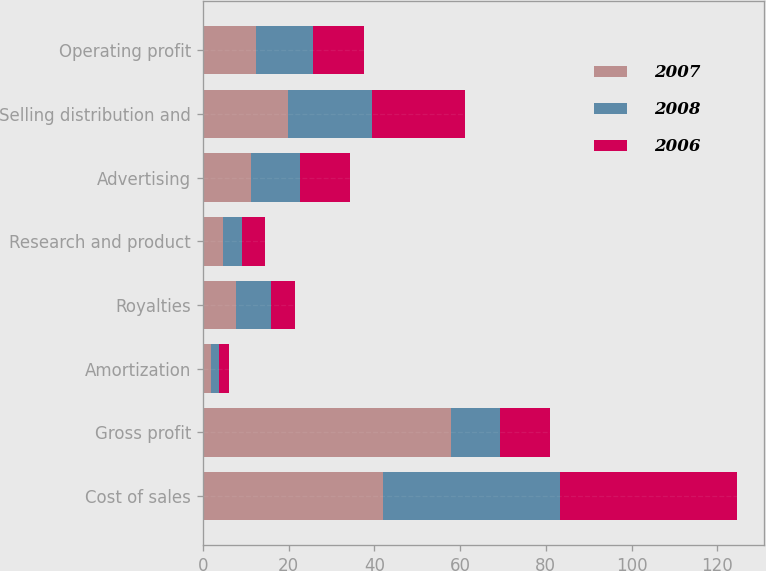Convert chart to OTSL. <chart><loc_0><loc_0><loc_500><loc_500><stacked_bar_chart><ecel><fcel>Cost of sales<fcel>Gross profit<fcel>Amortization<fcel>Royalties<fcel>Research and product<fcel>Advertising<fcel>Selling distribution and<fcel>Operating profit<nl><fcel>2007<fcel>42.1<fcel>57.9<fcel>1.9<fcel>7.8<fcel>4.8<fcel>11.3<fcel>19.8<fcel>12.3<nl><fcel>2008<fcel>41.1<fcel>11.5<fcel>1.8<fcel>8.2<fcel>4.4<fcel>11.3<fcel>19.7<fcel>13.5<nl><fcel>2006<fcel>41.4<fcel>11.5<fcel>2.5<fcel>5.4<fcel>5.4<fcel>11.7<fcel>21.7<fcel>11.9<nl></chart> 